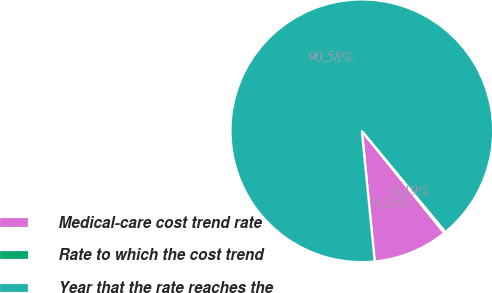Convert chart to OTSL. <chart><loc_0><loc_0><loc_500><loc_500><pie_chart><fcel>Medical-care cost trend rate<fcel>Rate to which the cost trend<fcel>Year that the rate reaches the<nl><fcel>9.23%<fcel>0.19%<fcel>90.58%<nl></chart> 